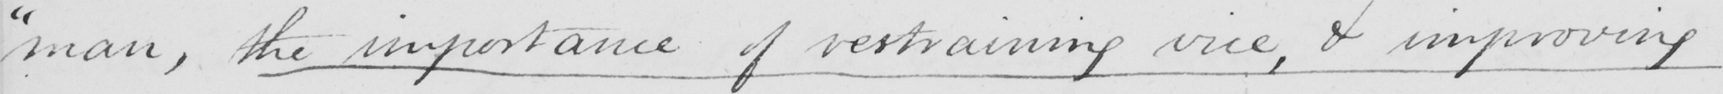Please provide the text content of this handwritten line. " man , the importance of restraining vice , & improving 